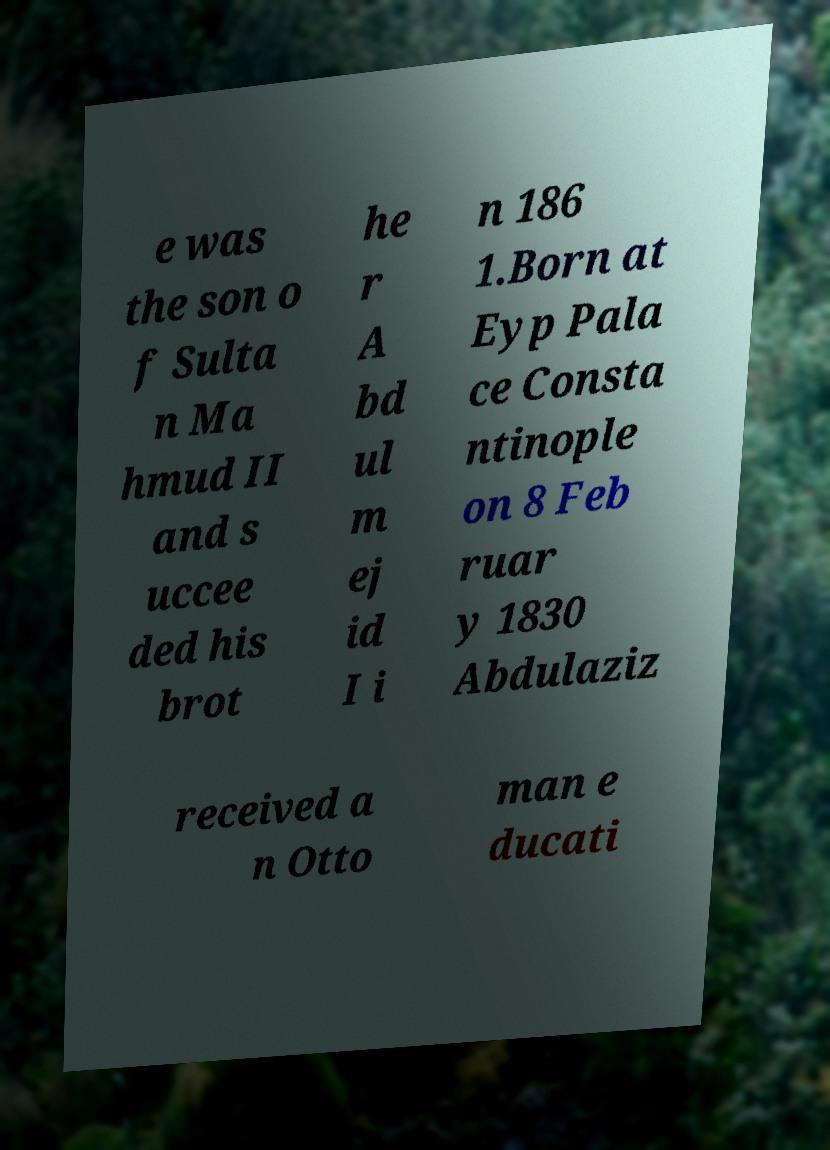I need the written content from this picture converted into text. Can you do that? e was the son o f Sulta n Ma hmud II and s uccee ded his brot he r A bd ul m ej id I i n 186 1.Born at Eyp Pala ce Consta ntinople on 8 Feb ruar y 1830 Abdulaziz received a n Otto man e ducati 